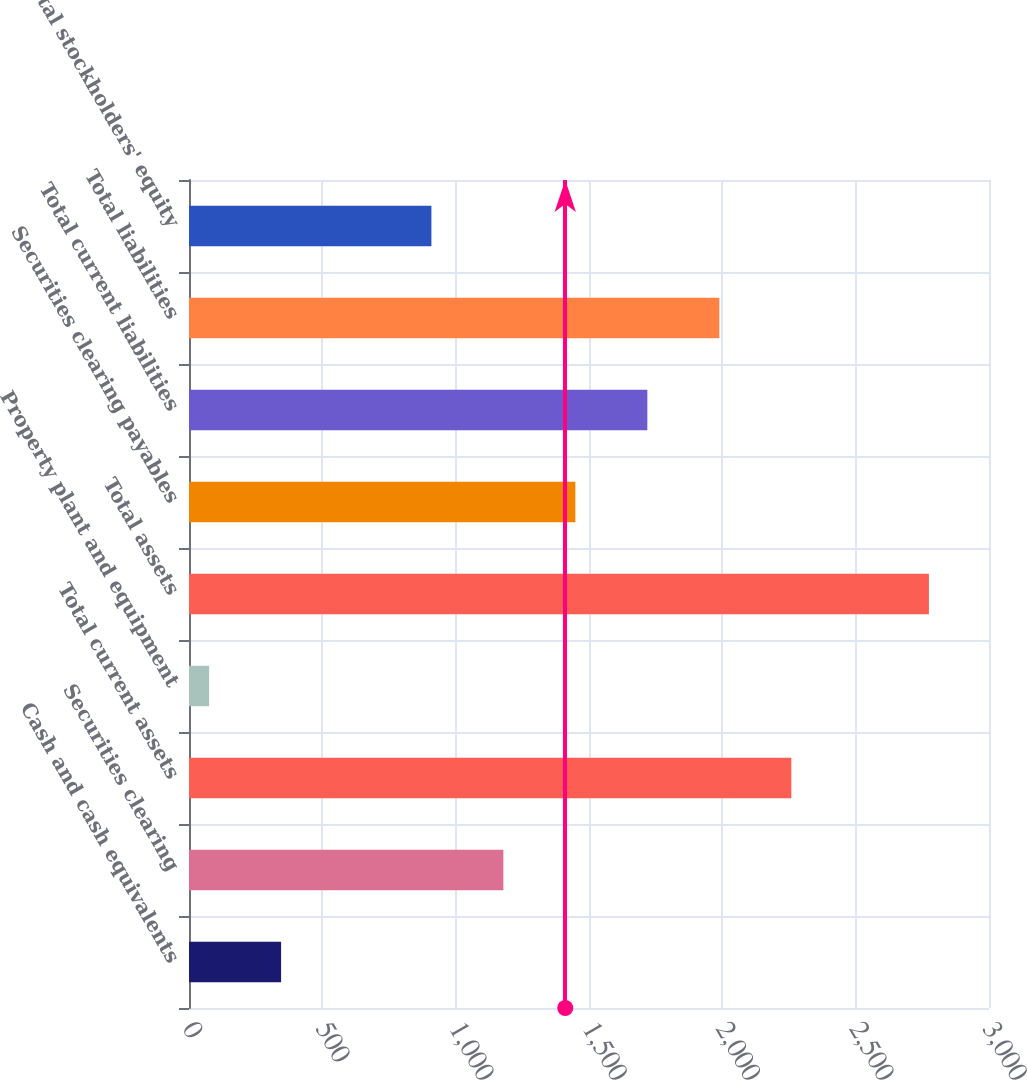Convert chart. <chart><loc_0><loc_0><loc_500><loc_500><bar_chart><fcel>Cash and cash equivalents<fcel>Securities clearing<fcel>Total current assets<fcel>Property plant and equipment<fcel>Total assets<fcel>Securities clearing payables<fcel>Total current liabilities<fcel>Total liabilities<fcel>Total stockholders' equity<nl><fcel>345.33<fcel>1178.93<fcel>2258.65<fcel>75.4<fcel>2774.7<fcel>1448.86<fcel>1718.79<fcel>1988.72<fcel>909<nl></chart> 